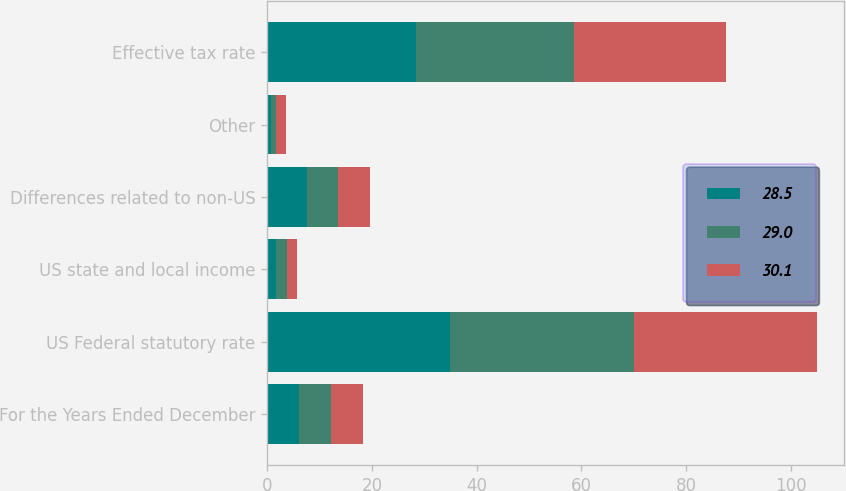Convert chart to OTSL. <chart><loc_0><loc_0><loc_500><loc_500><stacked_bar_chart><ecel><fcel>For the Years Ended December<fcel>US Federal statutory rate<fcel>US state and local income<fcel>Differences related to non-US<fcel>Other<fcel>Effective tax rate<nl><fcel>28.5<fcel>6.1<fcel>35<fcel>1.7<fcel>7.5<fcel>0.7<fcel>28.5<nl><fcel>29<fcel>6.1<fcel>35<fcel>2.1<fcel>6<fcel>1<fcel>30.1<nl><fcel>30.1<fcel>6.1<fcel>35<fcel>1.9<fcel>6.1<fcel>1.8<fcel>29<nl></chart> 